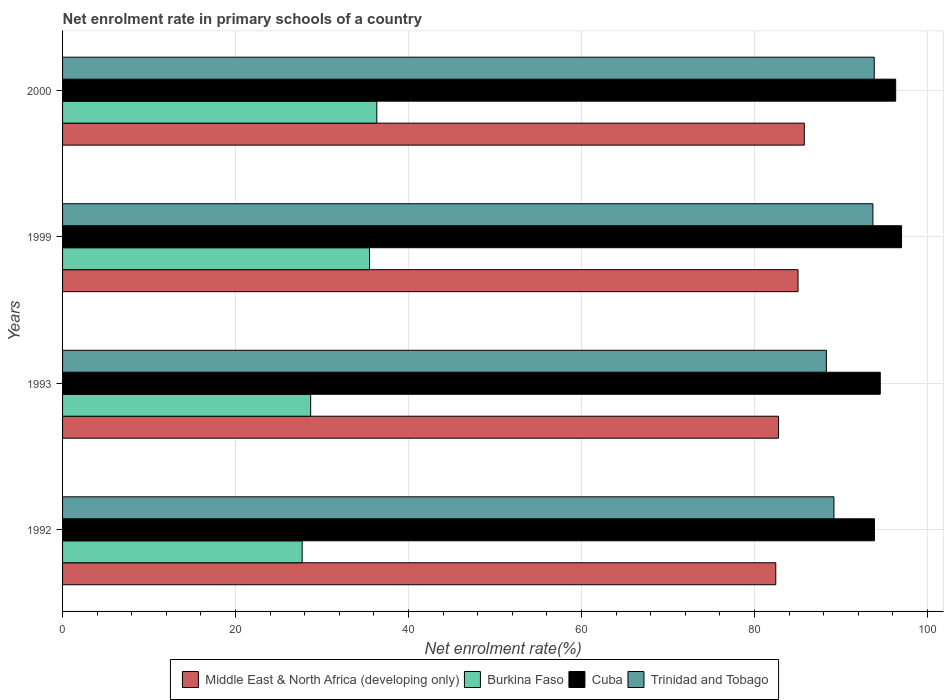How many bars are there on the 1st tick from the top?
Keep it short and to the point. 4. How many bars are there on the 2nd tick from the bottom?
Your answer should be compact. 4. In how many cases, is the number of bars for a given year not equal to the number of legend labels?
Give a very brief answer. 0. What is the net enrolment rate in primary schools in Trinidad and Tobago in 1992?
Your answer should be very brief. 89.2. Across all years, what is the maximum net enrolment rate in primary schools in Trinidad and Tobago?
Provide a succinct answer. 93.86. Across all years, what is the minimum net enrolment rate in primary schools in Middle East & North Africa (developing only)?
Offer a terse response. 82.47. In which year was the net enrolment rate in primary schools in Middle East & North Africa (developing only) maximum?
Offer a terse response. 2000. What is the total net enrolment rate in primary schools in Burkina Faso in the graph?
Your answer should be compact. 128.22. What is the difference between the net enrolment rate in primary schools in Cuba in 1992 and that in 1999?
Make the answer very short. -3.13. What is the difference between the net enrolment rate in primary schools in Cuba in 1993 and the net enrolment rate in primary schools in Middle East & North Africa (developing only) in 1992?
Offer a terse response. 12.08. What is the average net enrolment rate in primary schools in Middle East & North Africa (developing only) per year?
Provide a short and direct response. 84.02. In the year 1999, what is the difference between the net enrolment rate in primary schools in Trinidad and Tobago and net enrolment rate in primary schools in Cuba?
Offer a terse response. -3.31. In how many years, is the net enrolment rate in primary schools in Cuba greater than 8 %?
Offer a terse response. 4. What is the ratio of the net enrolment rate in primary schools in Middle East & North Africa (developing only) in 1993 to that in 2000?
Keep it short and to the point. 0.97. Is the net enrolment rate in primary schools in Middle East & North Africa (developing only) in 1992 less than that in 2000?
Your answer should be very brief. Yes. Is the difference between the net enrolment rate in primary schools in Trinidad and Tobago in 1993 and 1999 greater than the difference between the net enrolment rate in primary schools in Cuba in 1993 and 1999?
Keep it short and to the point. No. What is the difference between the highest and the second highest net enrolment rate in primary schools in Middle East & North Africa (developing only)?
Keep it short and to the point. 0.72. What is the difference between the highest and the lowest net enrolment rate in primary schools in Middle East & North Africa (developing only)?
Offer a terse response. 3.3. Is the sum of the net enrolment rate in primary schools in Trinidad and Tobago in 1993 and 1999 greater than the maximum net enrolment rate in primary schools in Burkina Faso across all years?
Offer a terse response. Yes. What does the 3rd bar from the top in 1999 represents?
Give a very brief answer. Burkina Faso. What does the 3rd bar from the bottom in 1999 represents?
Keep it short and to the point. Cuba. What is the difference between two consecutive major ticks on the X-axis?
Your answer should be compact. 20. Are the values on the major ticks of X-axis written in scientific E-notation?
Keep it short and to the point. No. Does the graph contain any zero values?
Your response must be concise. No. Does the graph contain grids?
Give a very brief answer. Yes. How many legend labels are there?
Keep it short and to the point. 4. What is the title of the graph?
Your answer should be very brief. Net enrolment rate in primary schools of a country. Does "Bahamas" appear as one of the legend labels in the graph?
Provide a succinct answer. No. What is the label or title of the X-axis?
Keep it short and to the point. Net enrolment rate(%). What is the Net enrolment rate(%) of Middle East & North Africa (developing only) in 1992?
Give a very brief answer. 82.47. What is the Net enrolment rate(%) in Burkina Faso in 1992?
Your answer should be compact. 27.7. What is the Net enrolment rate(%) in Cuba in 1992?
Your response must be concise. 93.88. What is the Net enrolment rate(%) in Trinidad and Tobago in 1992?
Offer a very short reply. 89.2. What is the Net enrolment rate(%) of Middle East & North Africa (developing only) in 1993?
Your answer should be very brief. 82.78. What is the Net enrolment rate(%) in Burkina Faso in 1993?
Ensure brevity in your answer.  28.69. What is the Net enrolment rate(%) in Cuba in 1993?
Provide a succinct answer. 94.55. What is the Net enrolment rate(%) in Trinidad and Tobago in 1993?
Your response must be concise. 88.32. What is the Net enrolment rate(%) in Middle East & North Africa (developing only) in 1999?
Your answer should be compact. 85.04. What is the Net enrolment rate(%) in Burkina Faso in 1999?
Keep it short and to the point. 35.49. What is the Net enrolment rate(%) in Cuba in 1999?
Your answer should be very brief. 97.01. What is the Net enrolment rate(%) of Trinidad and Tobago in 1999?
Your answer should be very brief. 93.7. What is the Net enrolment rate(%) in Middle East & North Africa (developing only) in 2000?
Keep it short and to the point. 85.77. What is the Net enrolment rate(%) in Burkina Faso in 2000?
Your answer should be compact. 36.33. What is the Net enrolment rate(%) in Cuba in 2000?
Give a very brief answer. 96.33. What is the Net enrolment rate(%) of Trinidad and Tobago in 2000?
Offer a very short reply. 93.86. Across all years, what is the maximum Net enrolment rate(%) in Middle East & North Africa (developing only)?
Make the answer very short. 85.77. Across all years, what is the maximum Net enrolment rate(%) of Burkina Faso?
Your response must be concise. 36.33. Across all years, what is the maximum Net enrolment rate(%) in Cuba?
Provide a short and direct response. 97.01. Across all years, what is the maximum Net enrolment rate(%) of Trinidad and Tobago?
Keep it short and to the point. 93.86. Across all years, what is the minimum Net enrolment rate(%) in Middle East & North Africa (developing only)?
Your response must be concise. 82.47. Across all years, what is the minimum Net enrolment rate(%) of Burkina Faso?
Offer a very short reply. 27.7. Across all years, what is the minimum Net enrolment rate(%) in Cuba?
Your answer should be very brief. 93.88. Across all years, what is the minimum Net enrolment rate(%) in Trinidad and Tobago?
Your response must be concise. 88.32. What is the total Net enrolment rate(%) in Middle East & North Africa (developing only) in the graph?
Offer a very short reply. 336.07. What is the total Net enrolment rate(%) of Burkina Faso in the graph?
Provide a succinct answer. 128.22. What is the total Net enrolment rate(%) in Cuba in the graph?
Your response must be concise. 381.78. What is the total Net enrolment rate(%) of Trinidad and Tobago in the graph?
Ensure brevity in your answer.  365.08. What is the difference between the Net enrolment rate(%) of Middle East & North Africa (developing only) in 1992 and that in 1993?
Make the answer very short. -0.31. What is the difference between the Net enrolment rate(%) of Burkina Faso in 1992 and that in 1993?
Your response must be concise. -0.98. What is the difference between the Net enrolment rate(%) of Cuba in 1992 and that in 1993?
Keep it short and to the point. -0.67. What is the difference between the Net enrolment rate(%) in Trinidad and Tobago in 1992 and that in 1993?
Give a very brief answer. 0.88. What is the difference between the Net enrolment rate(%) of Middle East & North Africa (developing only) in 1992 and that in 1999?
Keep it short and to the point. -2.57. What is the difference between the Net enrolment rate(%) of Burkina Faso in 1992 and that in 1999?
Offer a very short reply. -7.79. What is the difference between the Net enrolment rate(%) in Cuba in 1992 and that in 1999?
Make the answer very short. -3.13. What is the difference between the Net enrolment rate(%) in Trinidad and Tobago in 1992 and that in 1999?
Provide a succinct answer. -4.5. What is the difference between the Net enrolment rate(%) in Middle East & North Africa (developing only) in 1992 and that in 2000?
Ensure brevity in your answer.  -3.3. What is the difference between the Net enrolment rate(%) in Burkina Faso in 1992 and that in 2000?
Offer a very short reply. -8.63. What is the difference between the Net enrolment rate(%) of Cuba in 1992 and that in 2000?
Your answer should be very brief. -2.45. What is the difference between the Net enrolment rate(%) in Trinidad and Tobago in 1992 and that in 2000?
Offer a very short reply. -4.66. What is the difference between the Net enrolment rate(%) of Middle East & North Africa (developing only) in 1993 and that in 1999?
Keep it short and to the point. -2.26. What is the difference between the Net enrolment rate(%) of Burkina Faso in 1993 and that in 1999?
Your answer should be very brief. -6.8. What is the difference between the Net enrolment rate(%) of Cuba in 1993 and that in 1999?
Your response must be concise. -2.46. What is the difference between the Net enrolment rate(%) of Trinidad and Tobago in 1993 and that in 1999?
Offer a very short reply. -5.38. What is the difference between the Net enrolment rate(%) in Middle East & North Africa (developing only) in 1993 and that in 2000?
Offer a very short reply. -2.99. What is the difference between the Net enrolment rate(%) in Burkina Faso in 1993 and that in 2000?
Your answer should be compact. -7.65. What is the difference between the Net enrolment rate(%) of Cuba in 1993 and that in 2000?
Your response must be concise. -1.78. What is the difference between the Net enrolment rate(%) of Trinidad and Tobago in 1993 and that in 2000?
Ensure brevity in your answer.  -5.54. What is the difference between the Net enrolment rate(%) of Middle East & North Africa (developing only) in 1999 and that in 2000?
Make the answer very short. -0.72. What is the difference between the Net enrolment rate(%) of Burkina Faso in 1999 and that in 2000?
Provide a succinct answer. -0.84. What is the difference between the Net enrolment rate(%) of Cuba in 1999 and that in 2000?
Keep it short and to the point. 0.68. What is the difference between the Net enrolment rate(%) of Trinidad and Tobago in 1999 and that in 2000?
Offer a very short reply. -0.15. What is the difference between the Net enrolment rate(%) in Middle East & North Africa (developing only) in 1992 and the Net enrolment rate(%) in Burkina Faso in 1993?
Provide a short and direct response. 53.78. What is the difference between the Net enrolment rate(%) in Middle East & North Africa (developing only) in 1992 and the Net enrolment rate(%) in Cuba in 1993?
Your answer should be very brief. -12.08. What is the difference between the Net enrolment rate(%) in Middle East & North Africa (developing only) in 1992 and the Net enrolment rate(%) in Trinidad and Tobago in 1993?
Provide a short and direct response. -5.85. What is the difference between the Net enrolment rate(%) in Burkina Faso in 1992 and the Net enrolment rate(%) in Cuba in 1993?
Your response must be concise. -66.85. What is the difference between the Net enrolment rate(%) of Burkina Faso in 1992 and the Net enrolment rate(%) of Trinidad and Tobago in 1993?
Offer a very short reply. -60.62. What is the difference between the Net enrolment rate(%) in Cuba in 1992 and the Net enrolment rate(%) in Trinidad and Tobago in 1993?
Keep it short and to the point. 5.56. What is the difference between the Net enrolment rate(%) in Middle East & North Africa (developing only) in 1992 and the Net enrolment rate(%) in Burkina Faso in 1999?
Offer a very short reply. 46.98. What is the difference between the Net enrolment rate(%) of Middle East & North Africa (developing only) in 1992 and the Net enrolment rate(%) of Cuba in 1999?
Ensure brevity in your answer.  -14.54. What is the difference between the Net enrolment rate(%) of Middle East & North Africa (developing only) in 1992 and the Net enrolment rate(%) of Trinidad and Tobago in 1999?
Give a very brief answer. -11.23. What is the difference between the Net enrolment rate(%) of Burkina Faso in 1992 and the Net enrolment rate(%) of Cuba in 1999?
Make the answer very short. -69.31. What is the difference between the Net enrolment rate(%) of Burkina Faso in 1992 and the Net enrolment rate(%) of Trinidad and Tobago in 1999?
Make the answer very short. -66. What is the difference between the Net enrolment rate(%) of Cuba in 1992 and the Net enrolment rate(%) of Trinidad and Tobago in 1999?
Give a very brief answer. 0.18. What is the difference between the Net enrolment rate(%) in Middle East & North Africa (developing only) in 1992 and the Net enrolment rate(%) in Burkina Faso in 2000?
Ensure brevity in your answer.  46.13. What is the difference between the Net enrolment rate(%) of Middle East & North Africa (developing only) in 1992 and the Net enrolment rate(%) of Cuba in 2000?
Provide a short and direct response. -13.86. What is the difference between the Net enrolment rate(%) in Middle East & North Africa (developing only) in 1992 and the Net enrolment rate(%) in Trinidad and Tobago in 2000?
Provide a short and direct response. -11.39. What is the difference between the Net enrolment rate(%) of Burkina Faso in 1992 and the Net enrolment rate(%) of Cuba in 2000?
Make the answer very short. -68.63. What is the difference between the Net enrolment rate(%) of Burkina Faso in 1992 and the Net enrolment rate(%) of Trinidad and Tobago in 2000?
Provide a short and direct response. -66.15. What is the difference between the Net enrolment rate(%) of Cuba in 1992 and the Net enrolment rate(%) of Trinidad and Tobago in 2000?
Provide a succinct answer. 0.03. What is the difference between the Net enrolment rate(%) in Middle East & North Africa (developing only) in 1993 and the Net enrolment rate(%) in Burkina Faso in 1999?
Give a very brief answer. 47.29. What is the difference between the Net enrolment rate(%) of Middle East & North Africa (developing only) in 1993 and the Net enrolment rate(%) of Cuba in 1999?
Ensure brevity in your answer.  -14.23. What is the difference between the Net enrolment rate(%) in Middle East & North Africa (developing only) in 1993 and the Net enrolment rate(%) in Trinidad and Tobago in 1999?
Offer a terse response. -10.92. What is the difference between the Net enrolment rate(%) of Burkina Faso in 1993 and the Net enrolment rate(%) of Cuba in 1999?
Offer a terse response. -68.33. What is the difference between the Net enrolment rate(%) of Burkina Faso in 1993 and the Net enrolment rate(%) of Trinidad and Tobago in 1999?
Provide a short and direct response. -65.02. What is the difference between the Net enrolment rate(%) of Cuba in 1993 and the Net enrolment rate(%) of Trinidad and Tobago in 1999?
Provide a succinct answer. 0.85. What is the difference between the Net enrolment rate(%) of Middle East & North Africa (developing only) in 1993 and the Net enrolment rate(%) of Burkina Faso in 2000?
Provide a short and direct response. 46.45. What is the difference between the Net enrolment rate(%) in Middle East & North Africa (developing only) in 1993 and the Net enrolment rate(%) in Cuba in 2000?
Your answer should be compact. -13.55. What is the difference between the Net enrolment rate(%) in Middle East & North Africa (developing only) in 1993 and the Net enrolment rate(%) in Trinidad and Tobago in 2000?
Make the answer very short. -11.07. What is the difference between the Net enrolment rate(%) in Burkina Faso in 1993 and the Net enrolment rate(%) in Cuba in 2000?
Make the answer very short. -67.65. What is the difference between the Net enrolment rate(%) of Burkina Faso in 1993 and the Net enrolment rate(%) of Trinidad and Tobago in 2000?
Keep it short and to the point. -65.17. What is the difference between the Net enrolment rate(%) of Cuba in 1993 and the Net enrolment rate(%) of Trinidad and Tobago in 2000?
Make the answer very short. 0.7. What is the difference between the Net enrolment rate(%) in Middle East & North Africa (developing only) in 1999 and the Net enrolment rate(%) in Burkina Faso in 2000?
Offer a very short reply. 48.71. What is the difference between the Net enrolment rate(%) of Middle East & North Africa (developing only) in 1999 and the Net enrolment rate(%) of Cuba in 2000?
Your answer should be compact. -11.29. What is the difference between the Net enrolment rate(%) of Middle East & North Africa (developing only) in 1999 and the Net enrolment rate(%) of Trinidad and Tobago in 2000?
Give a very brief answer. -8.81. What is the difference between the Net enrolment rate(%) in Burkina Faso in 1999 and the Net enrolment rate(%) in Cuba in 2000?
Offer a very short reply. -60.84. What is the difference between the Net enrolment rate(%) in Burkina Faso in 1999 and the Net enrolment rate(%) in Trinidad and Tobago in 2000?
Provide a succinct answer. -58.36. What is the difference between the Net enrolment rate(%) of Cuba in 1999 and the Net enrolment rate(%) of Trinidad and Tobago in 2000?
Offer a terse response. 3.16. What is the average Net enrolment rate(%) in Middle East & North Africa (developing only) per year?
Make the answer very short. 84.02. What is the average Net enrolment rate(%) of Burkina Faso per year?
Your answer should be very brief. 32.05. What is the average Net enrolment rate(%) in Cuba per year?
Your answer should be compact. 95.45. What is the average Net enrolment rate(%) of Trinidad and Tobago per year?
Your response must be concise. 91.27. In the year 1992, what is the difference between the Net enrolment rate(%) of Middle East & North Africa (developing only) and Net enrolment rate(%) of Burkina Faso?
Give a very brief answer. 54.77. In the year 1992, what is the difference between the Net enrolment rate(%) in Middle East & North Africa (developing only) and Net enrolment rate(%) in Cuba?
Your response must be concise. -11.41. In the year 1992, what is the difference between the Net enrolment rate(%) in Middle East & North Africa (developing only) and Net enrolment rate(%) in Trinidad and Tobago?
Your answer should be compact. -6.73. In the year 1992, what is the difference between the Net enrolment rate(%) of Burkina Faso and Net enrolment rate(%) of Cuba?
Keep it short and to the point. -66.18. In the year 1992, what is the difference between the Net enrolment rate(%) in Burkina Faso and Net enrolment rate(%) in Trinidad and Tobago?
Ensure brevity in your answer.  -61.49. In the year 1992, what is the difference between the Net enrolment rate(%) of Cuba and Net enrolment rate(%) of Trinidad and Tobago?
Offer a terse response. 4.68. In the year 1993, what is the difference between the Net enrolment rate(%) in Middle East & North Africa (developing only) and Net enrolment rate(%) in Burkina Faso?
Give a very brief answer. 54.1. In the year 1993, what is the difference between the Net enrolment rate(%) in Middle East & North Africa (developing only) and Net enrolment rate(%) in Cuba?
Provide a succinct answer. -11.77. In the year 1993, what is the difference between the Net enrolment rate(%) of Middle East & North Africa (developing only) and Net enrolment rate(%) of Trinidad and Tobago?
Offer a very short reply. -5.54. In the year 1993, what is the difference between the Net enrolment rate(%) in Burkina Faso and Net enrolment rate(%) in Cuba?
Your response must be concise. -65.87. In the year 1993, what is the difference between the Net enrolment rate(%) in Burkina Faso and Net enrolment rate(%) in Trinidad and Tobago?
Ensure brevity in your answer.  -59.63. In the year 1993, what is the difference between the Net enrolment rate(%) of Cuba and Net enrolment rate(%) of Trinidad and Tobago?
Keep it short and to the point. 6.23. In the year 1999, what is the difference between the Net enrolment rate(%) of Middle East & North Africa (developing only) and Net enrolment rate(%) of Burkina Faso?
Your response must be concise. 49.55. In the year 1999, what is the difference between the Net enrolment rate(%) in Middle East & North Africa (developing only) and Net enrolment rate(%) in Cuba?
Make the answer very short. -11.97. In the year 1999, what is the difference between the Net enrolment rate(%) in Middle East & North Africa (developing only) and Net enrolment rate(%) in Trinidad and Tobago?
Your response must be concise. -8.66. In the year 1999, what is the difference between the Net enrolment rate(%) of Burkina Faso and Net enrolment rate(%) of Cuba?
Provide a succinct answer. -61.52. In the year 1999, what is the difference between the Net enrolment rate(%) in Burkina Faso and Net enrolment rate(%) in Trinidad and Tobago?
Give a very brief answer. -58.21. In the year 1999, what is the difference between the Net enrolment rate(%) of Cuba and Net enrolment rate(%) of Trinidad and Tobago?
Provide a short and direct response. 3.31. In the year 2000, what is the difference between the Net enrolment rate(%) of Middle East & North Africa (developing only) and Net enrolment rate(%) of Burkina Faso?
Provide a short and direct response. 49.43. In the year 2000, what is the difference between the Net enrolment rate(%) in Middle East & North Africa (developing only) and Net enrolment rate(%) in Cuba?
Offer a terse response. -10.56. In the year 2000, what is the difference between the Net enrolment rate(%) in Middle East & North Africa (developing only) and Net enrolment rate(%) in Trinidad and Tobago?
Give a very brief answer. -8.09. In the year 2000, what is the difference between the Net enrolment rate(%) of Burkina Faso and Net enrolment rate(%) of Cuba?
Give a very brief answer. -60. In the year 2000, what is the difference between the Net enrolment rate(%) in Burkina Faso and Net enrolment rate(%) in Trinidad and Tobago?
Make the answer very short. -57.52. In the year 2000, what is the difference between the Net enrolment rate(%) of Cuba and Net enrolment rate(%) of Trinidad and Tobago?
Keep it short and to the point. 2.48. What is the ratio of the Net enrolment rate(%) of Middle East & North Africa (developing only) in 1992 to that in 1993?
Provide a succinct answer. 1. What is the ratio of the Net enrolment rate(%) in Burkina Faso in 1992 to that in 1993?
Ensure brevity in your answer.  0.97. What is the ratio of the Net enrolment rate(%) of Middle East & North Africa (developing only) in 1992 to that in 1999?
Give a very brief answer. 0.97. What is the ratio of the Net enrolment rate(%) of Burkina Faso in 1992 to that in 1999?
Offer a very short reply. 0.78. What is the ratio of the Net enrolment rate(%) of Trinidad and Tobago in 1992 to that in 1999?
Ensure brevity in your answer.  0.95. What is the ratio of the Net enrolment rate(%) in Middle East & North Africa (developing only) in 1992 to that in 2000?
Your answer should be compact. 0.96. What is the ratio of the Net enrolment rate(%) of Burkina Faso in 1992 to that in 2000?
Your answer should be very brief. 0.76. What is the ratio of the Net enrolment rate(%) in Cuba in 1992 to that in 2000?
Your response must be concise. 0.97. What is the ratio of the Net enrolment rate(%) of Trinidad and Tobago in 1992 to that in 2000?
Your response must be concise. 0.95. What is the ratio of the Net enrolment rate(%) in Middle East & North Africa (developing only) in 1993 to that in 1999?
Give a very brief answer. 0.97. What is the ratio of the Net enrolment rate(%) of Burkina Faso in 1993 to that in 1999?
Make the answer very short. 0.81. What is the ratio of the Net enrolment rate(%) of Cuba in 1993 to that in 1999?
Provide a succinct answer. 0.97. What is the ratio of the Net enrolment rate(%) in Trinidad and Tobago in 1993 to that in 1999?
Your answer should be compact. 0.94. What is the ratio of the Net enrolment rate(%) of Middle East & North Africa (developing only) in 1993 to that in 2000?
Ensure brevity in your answer.  0.97. What is the ratio of the Net enrolment rate(%) in Burkina Faso in 1993 to that in 2000?
Provide a short and direct response. 0.79. What is the ratio of the Net enrolment rate(%) in Cuba in 1993 to that in 2000?
Make the answer very short. 0.98. What is the ratio of the Net enrolment rate(%) in Trinidad and Tobago in 1993 to that in 2000?
Your answer should be compact. 0.94. What is the ratio of the Net enrolment rate(%) of Middle East & North Africa (developing only) in 1999 to that in 2000?
Provide a succinct answer. 0.99. What is the ratio of the Net enrolment rate(%) in Burkina Faso in 1999 to that in 2000?
Offer a terse response. 0.98. What is the ratio of the Net enrolment rate(%) in Cuba in 1999 to that in 2000?
Your response must be concise. 1.01. What is the ratio of the Net enrolment rate(%) of Trinidad and Tobago in 1999 to that in 2000?
Provide a short and direct response. 1. What is the difference between the highest and the second highest Net enrolment rate(%) of Middle East & North Africa (developing only)?
Ensure brevity in your answer.  0.72. What is the difference between the highest and the second highest Net enrolment rate(%) of Burkina Faso?
Make the answer very short. 0.84. What is the difference between the highest and the second highest Net enrolment rate(%) of Cuba?
Ensure brevity in your answer.  0.68. What is the difference between the highest and the second highest Net enrolment rate(%) of Trinidad and Tobago?
Offer a terse response. 0.15. What is the difference between the highest and the lowest Net enrolment rate(%) in Middle East & North Africa (developing only)?
Your answer should be very brief. 3.3. What is the difference between the highest and the lowest Net enrolment rate(%) in Burkina Faso?
Give a very brief answer. 8.63. What is the difference between the highest and the lowest Net enrolment rate(%) of Cuba?
Offer a very short reply. 3.13. What is the difference between the highest and the lowest Net enrolment rate(%) of Trinidad and Tobago?
Keep it short and to the point. 5.54. 